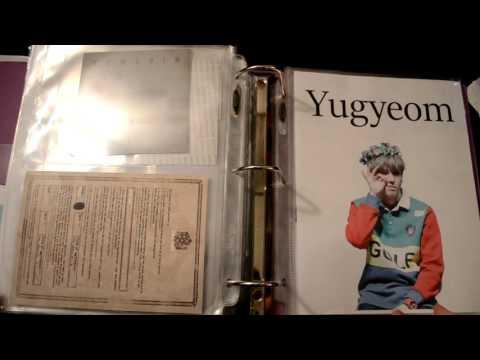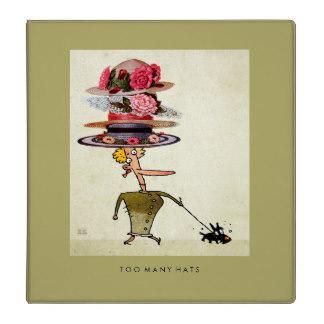The first image is the image on the left, the second image is the image on the right. Examine the images to the left and right. Is the description "A woman holds a pile of binders." accurate? Answer yes or no. No. The first image is the image on the left, the second image is the image on the right. Examine the images to the left and right. Is the description "A person's arms wrap around a bunch of binders in one image." accurate? Answer yes or no. No. 